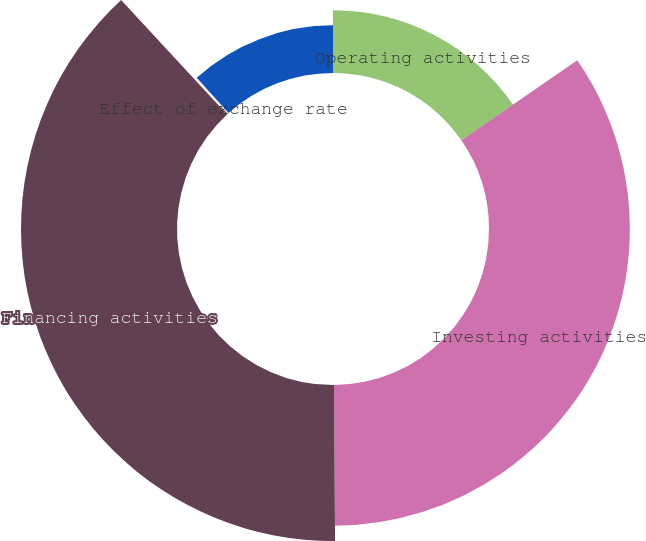Convert chart to OTSL. <chart><loc_0><loc_0><loc_500><loc_500><pie_chart><fcel>Operating activities<fcel>Investing activities<fcel>Financing activities<fcel>Effect of exchange rate<fcel>Net change in cash and cash<nl><fcel>15.38%<fcel>34.51%<fcel>38.22%<fcel>0.21%<fcel>11.67%<nl></chart> 